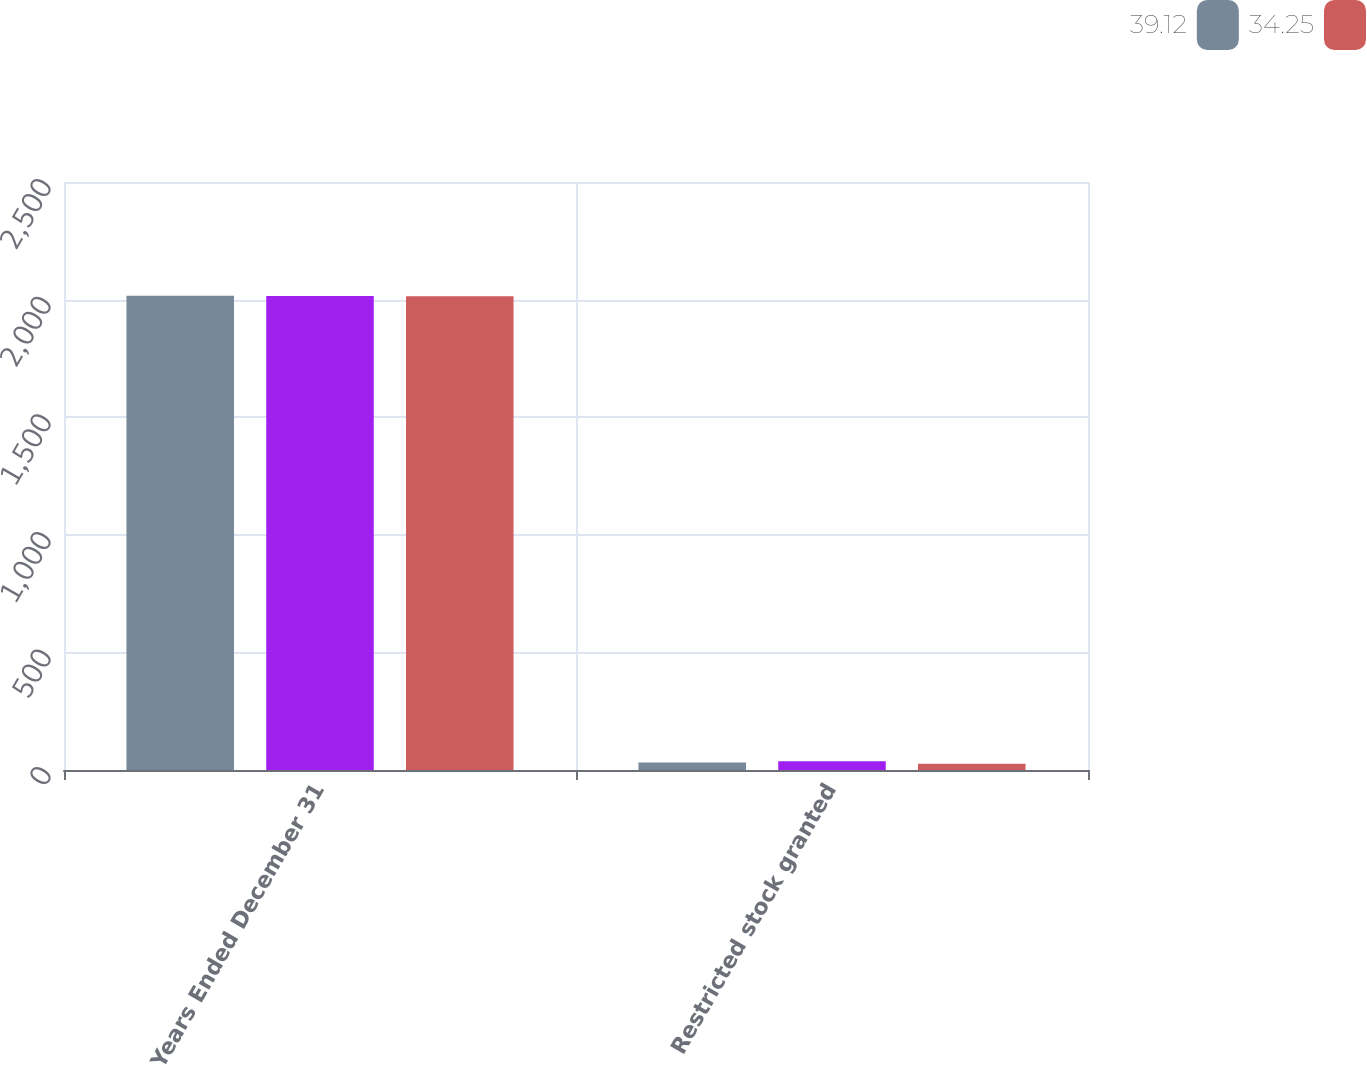Convert chart. <chart><loc_0><loc_0><loc_500><loc_500><stacked_bar_chart><ecel><fcel>Years Ended December 31<fcel>Restricted stock granted<nl><fcel>39.12<fcel>2016<fcel>31.74<nl><fcel>nan<fcel>2015<fcel>36.84<nl><fcel>34.25<fcel>2014<fcel>26.15<nl></chart> 